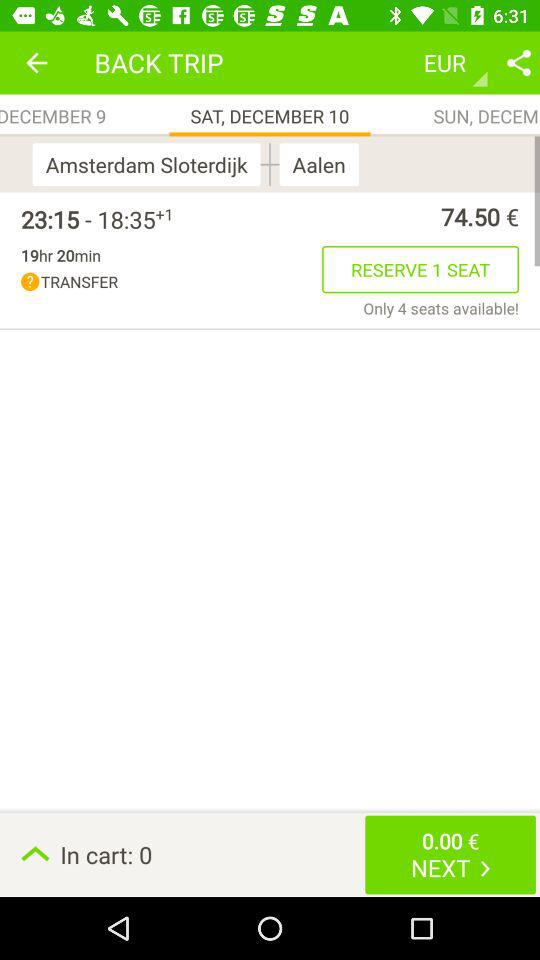How many seats are available?
Answer the question using a single word or phrase. 4 